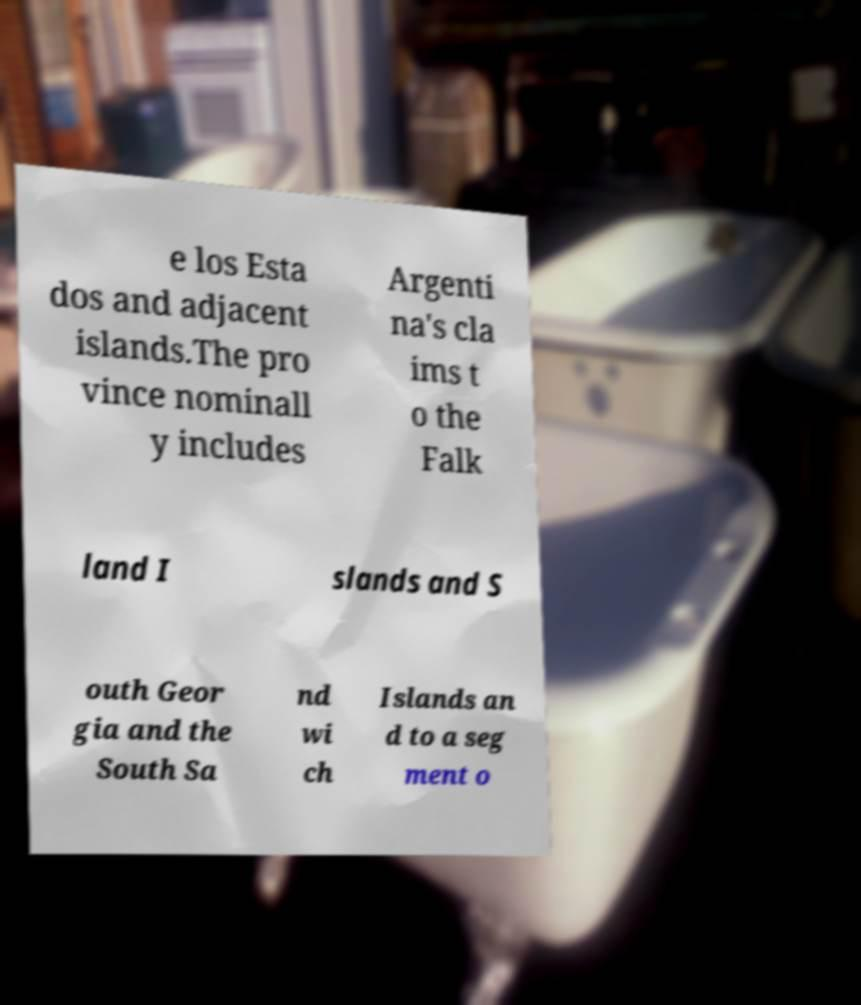Please read and relay the text visible in this image. What does it say? e los Esta dos and adjacent islands.The pro vince nominall y includes Argenti na's cla ims t o the Falk land I slands and S outh Geor gia and the South Sa nd wi ch Islands an d to a seg ment o 